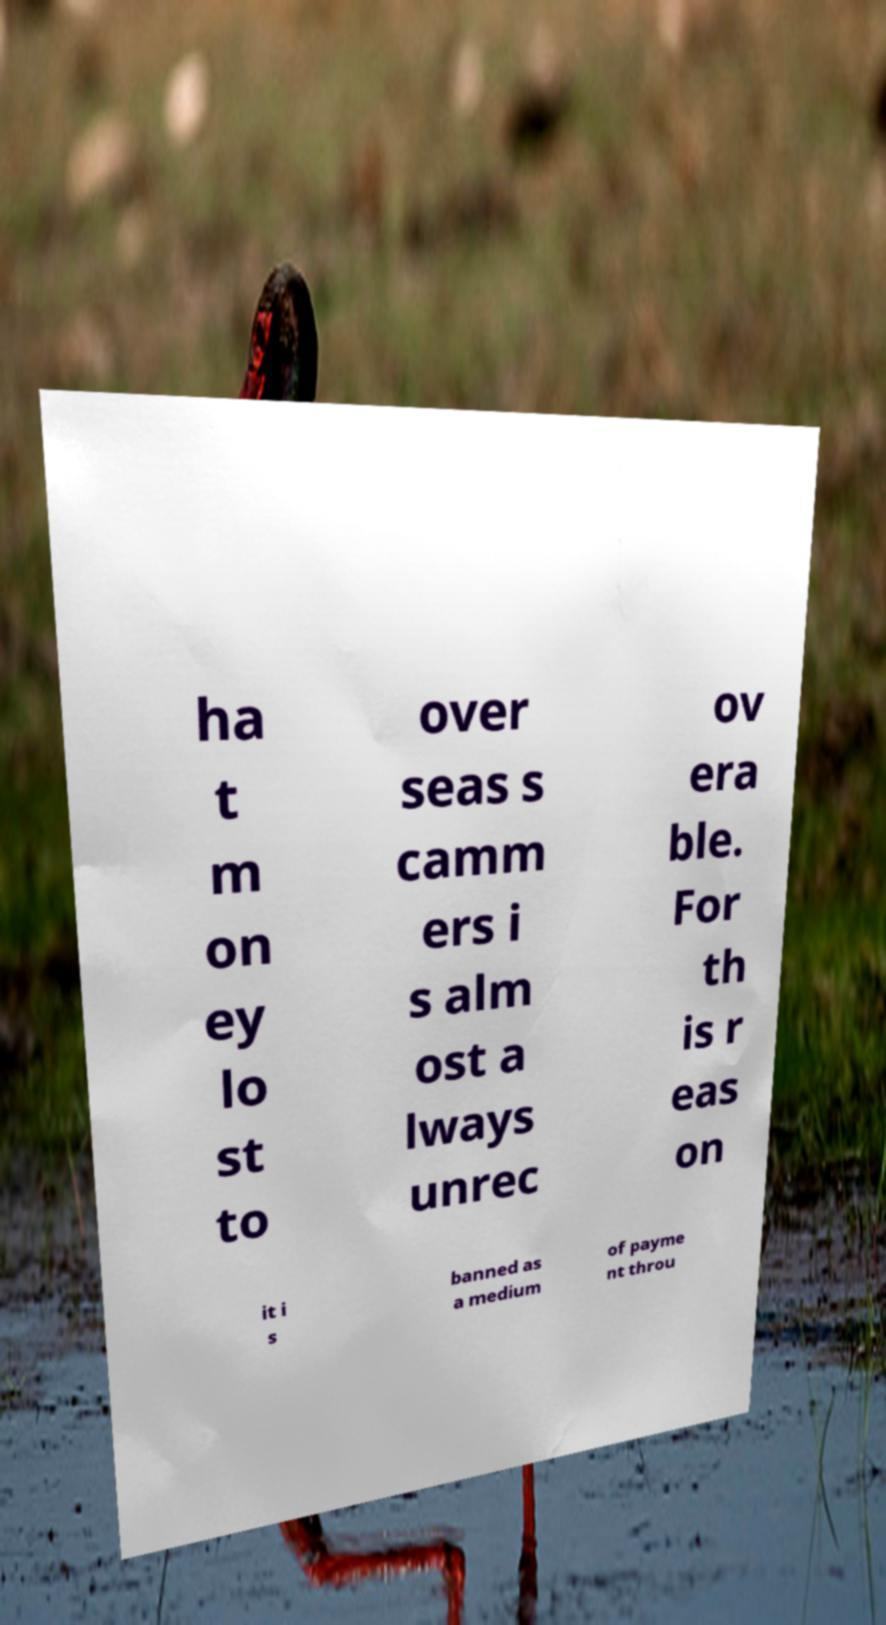There's text embedded in this image that I need extracted. Can you transcribe it verbatim? ha t m on ey lo st to over seas s camm ers i s alm ost a lways unrec ov era ble. For th is r eas on it i s banned as a medium of payme nt throu 